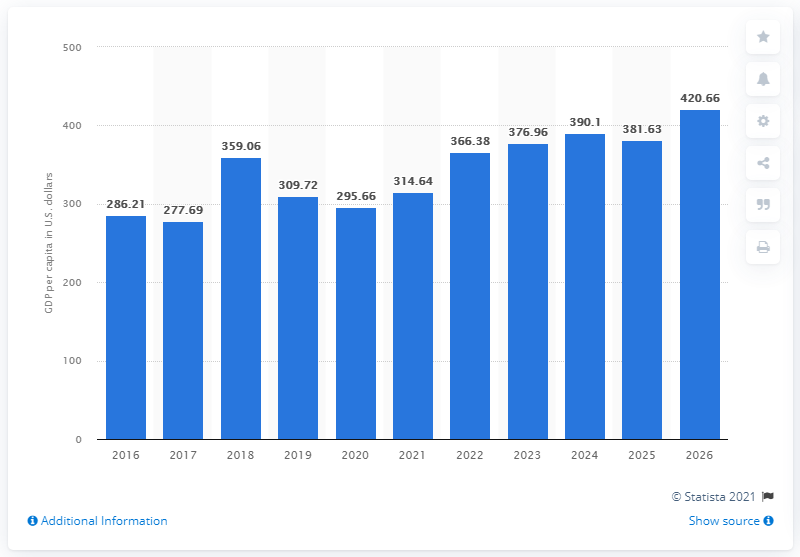Mention a couple of crucial points in this snapshot. In 2020, the estimated GDP per capita in South Sudan was 295.66. 